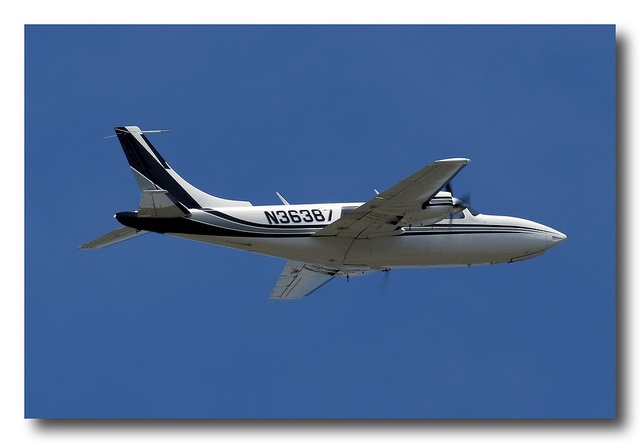Describe the objects in this image and their specific colors. I can see a airplane in white, gray, black, and lightgray tones in this image. 